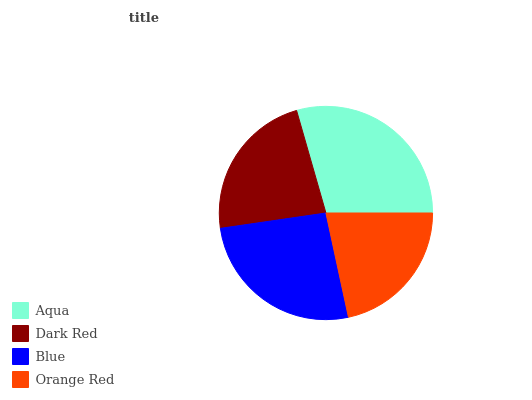Is Orange Red the minimum?
Answer yes or no. Yes. Is Aqua the maximum?
Answer yes or no. Yes. Is Dark Red the minimum?
Answer yes or no. No. Is Dark Red the maximum?
Answer yes or no. No. Is Aqua greater than Dark Red?
Answer yes or no. Yes. Is Dark Red less than Aqua?
Answer yes or no. Yes. Is Dark Red greater than Aqua?
Answer yes or no. No. Is Aqua less than Dark Red?
Answer yes or no. No. Is Blue the high median?
Answer yes or no. Yes. Is Dark Red the low median?
Answer yes or no. Yes. Is Aqua the high median?
Answer yes or no. No. Is Aqua the low median?
Answer yes or no. No. 